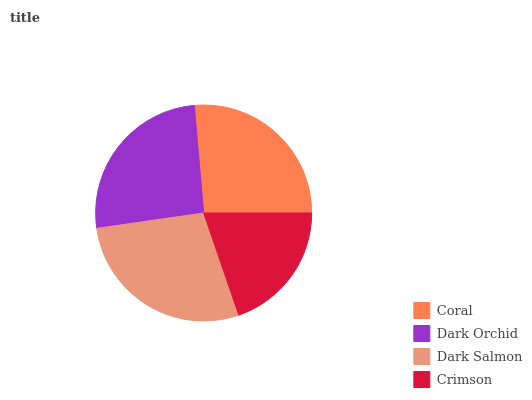Is Crimson the minimum?
Answer yes or no. Yes. Is Dark Salmon the maximum?
Answer yes or no. Yes. Is Dark Orchid the minimum?
Answer yes or no. No. Is Dark Orchid the maximum?
Answer yes or no. No. Is Coral greater than Dark Orchid?
Answer yes or no. Yes. Is Dark Orchid less than Coral?
Answer yes or no. Yes. Is Dark Orchid greater than Coral?
Answer yes or no. No. Is Coral less than Dark Orchid?
Answer yes or no. No. Is Coral the high median?
Answer yes or no. Yes. Is Dark Orchid the low median?
Answer yes or no. Yes. Is Dark Orchid the high median?
Answer yes or no. No. Is Crimson the low median?
Answer yes or no. No. 